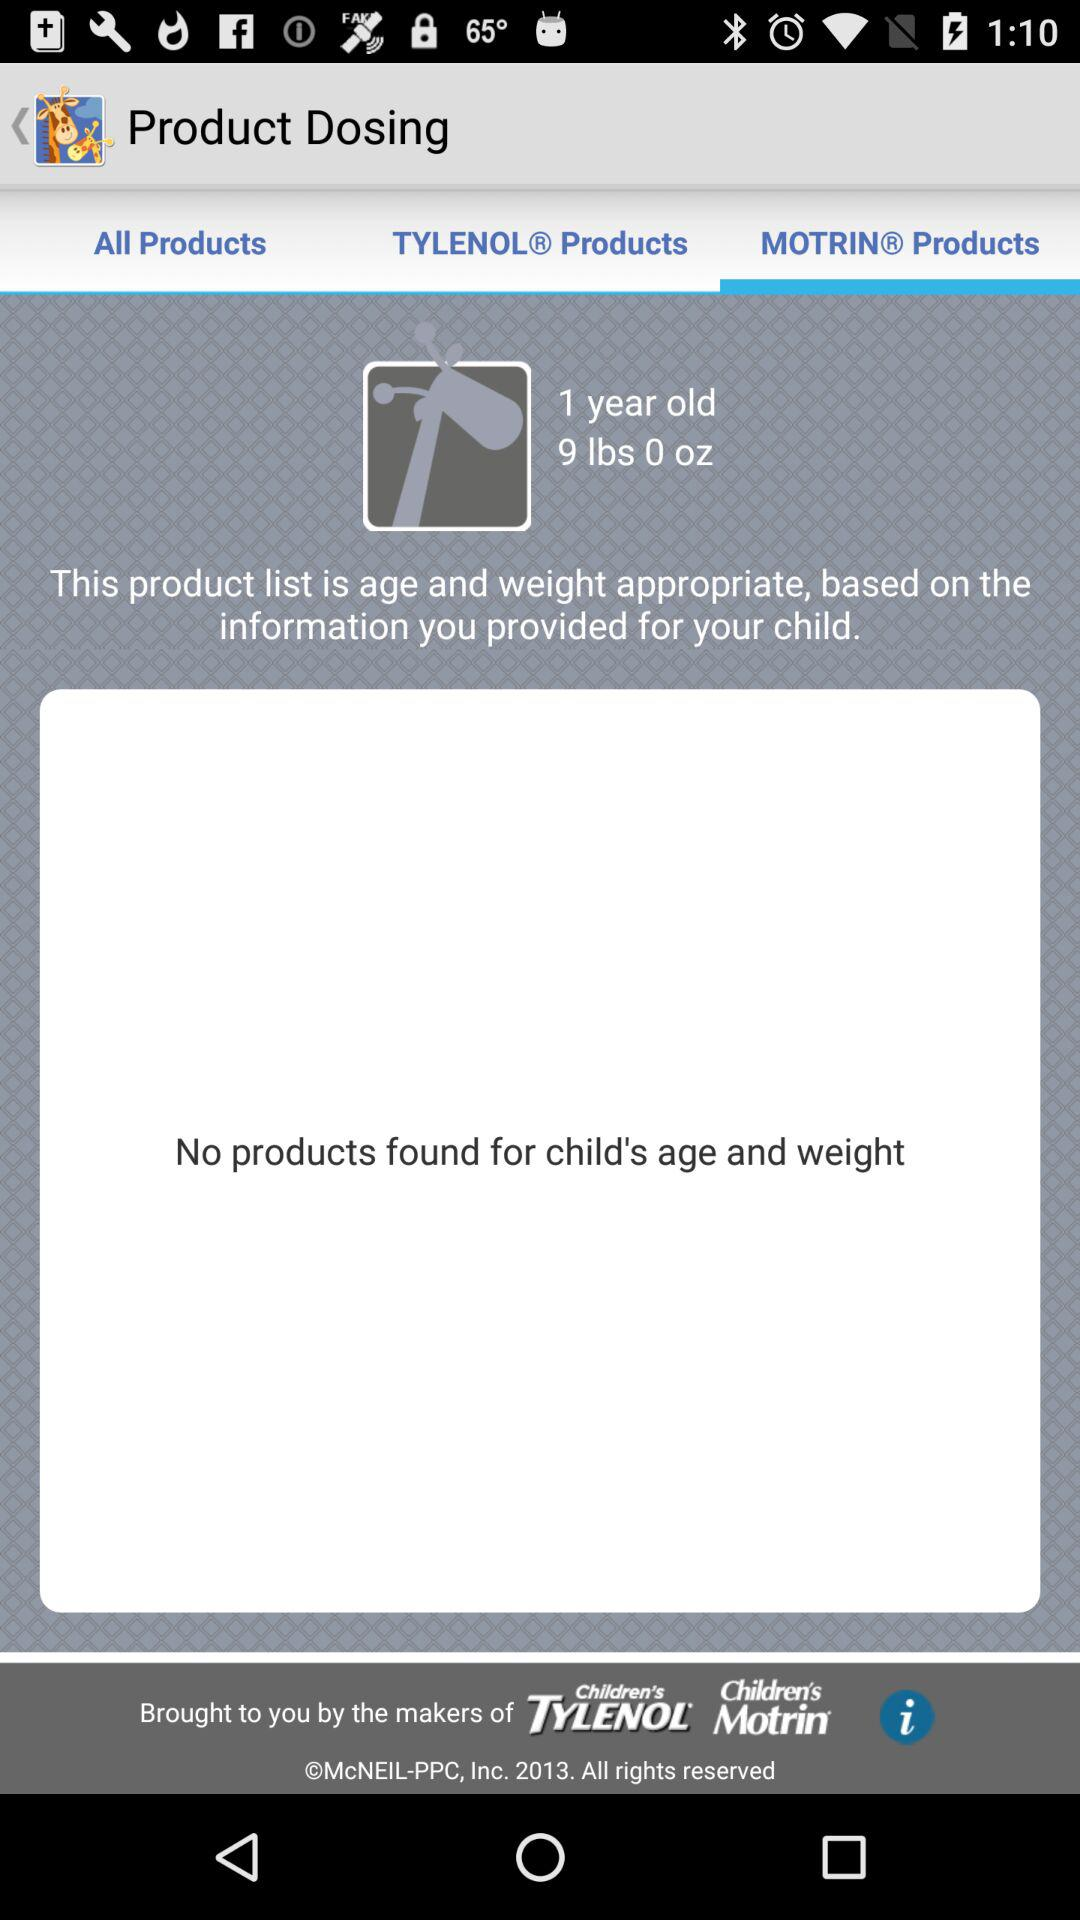What's the age of the child? The child is 1 year old. 